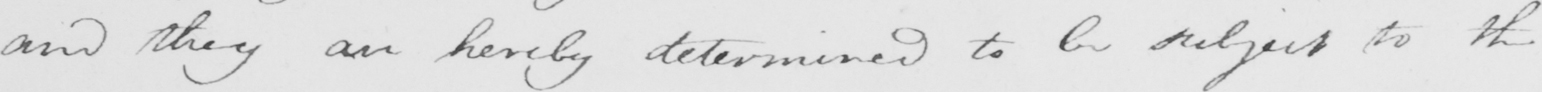What text is written in this handwritten line? and they are hereby determined to be subject to the 